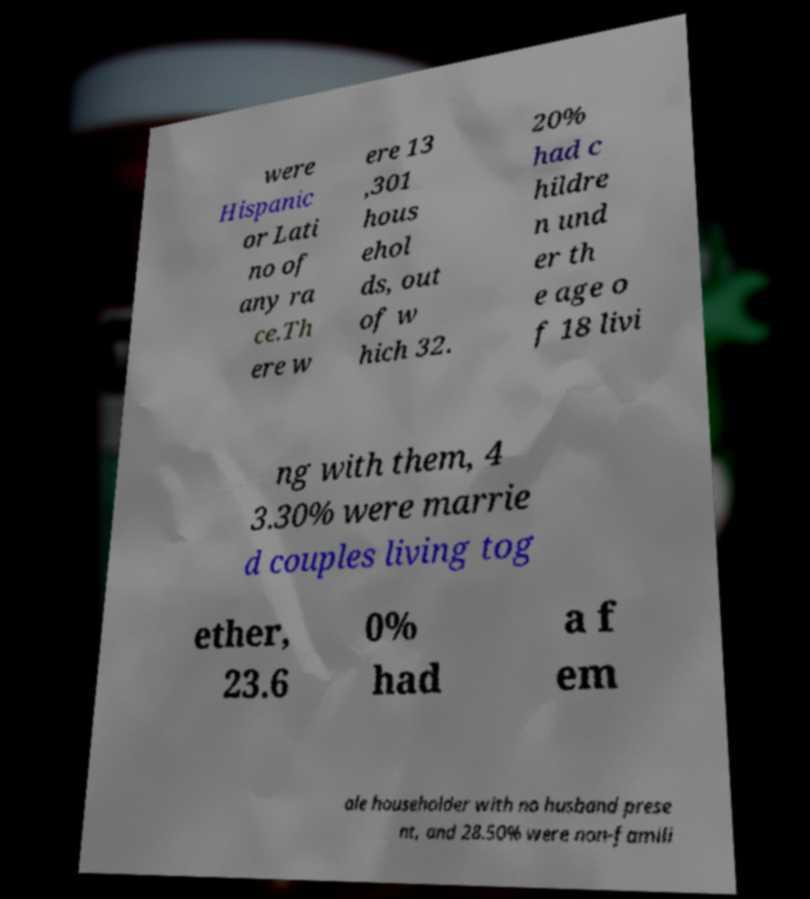Could you assist in decoding the text presented in this image and type it out clearly? were Hispanic or Lati no of any ra ce.Th ere w ere 13 ,301 hous ehol ds, out of w hich 32. 20% had c hildre n und er th e age o f 18 livi ng with them, 4 3.30% were marrie d couples living tog ether, 23.6 0% had a f em ale householder with no husband prese nt, and 28.50% were non-famili 